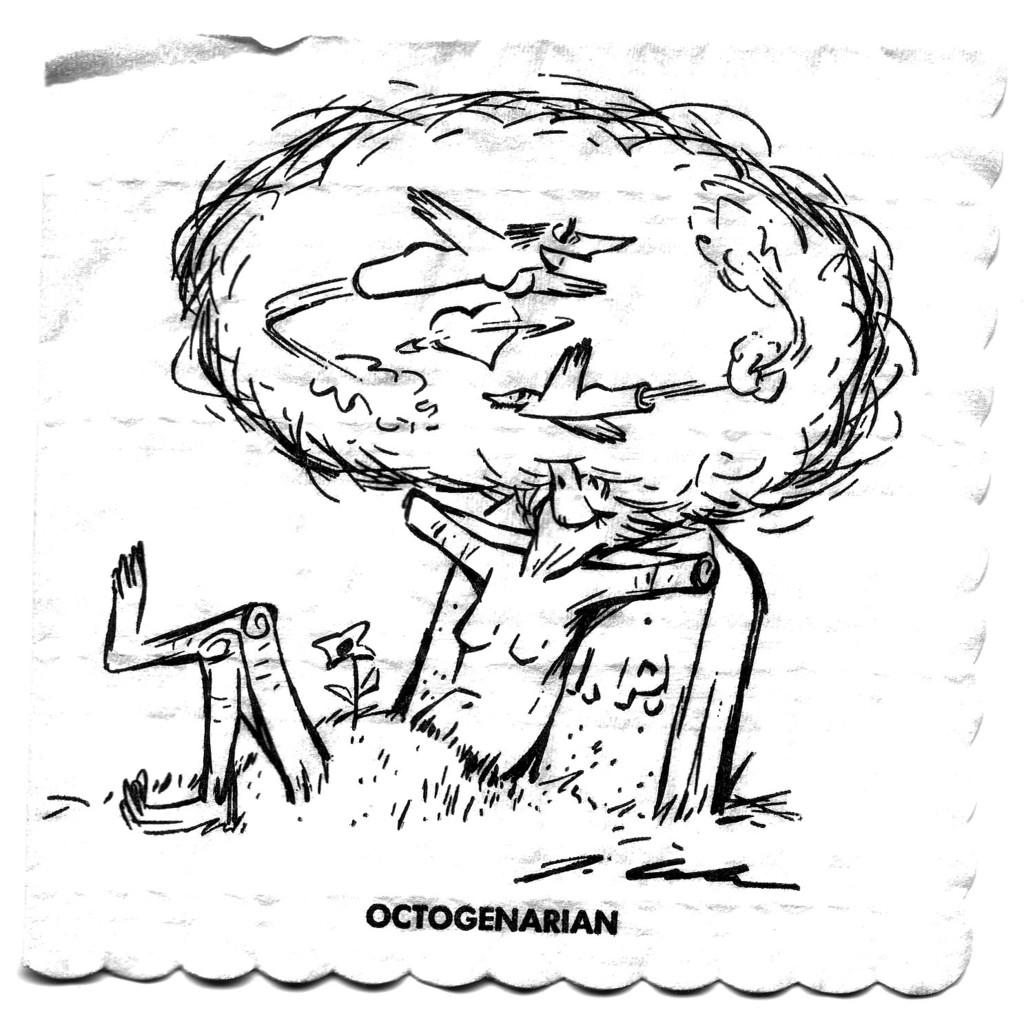What is depicted in the image? There is a sketch of a person in the image. What is the person in the sketch doing? The person in the sketch appears to be dreaming. What type of amusement can be seen on the table in the image? There is no table or amusement present in the image; it only features a sketch of a person dreaming. 